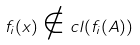Convert formula to latex. <formula><loc_0><loc_0><loc_500><loc_500>f _ { i } ( x ) \notin c l ( f _ { i } ( A ) )</formula> 